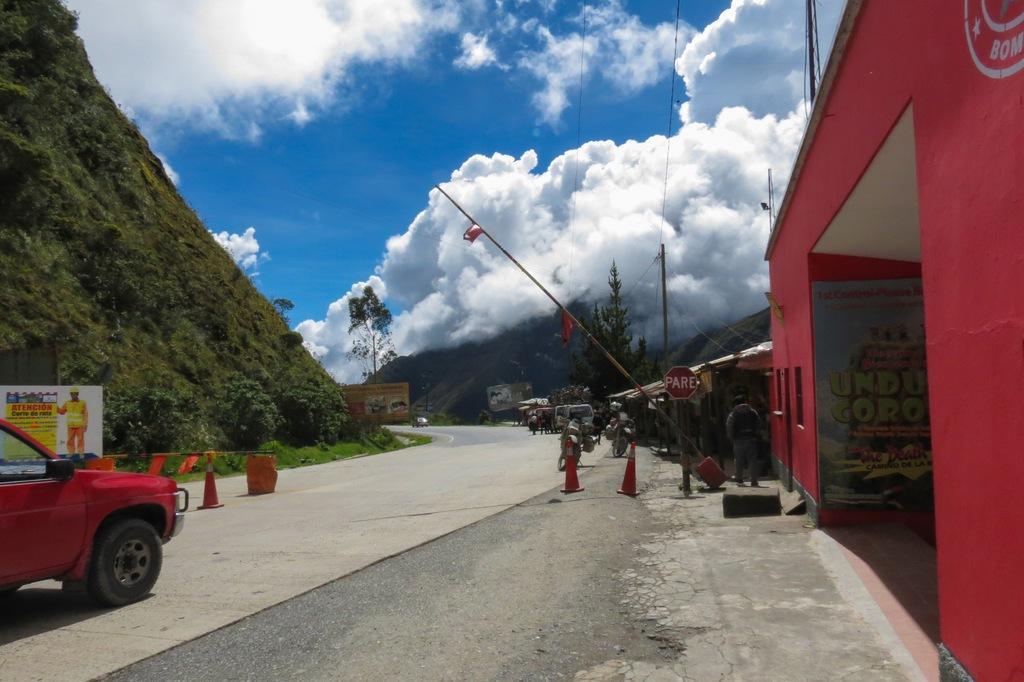Describe this image in one or two sentences. In this picture i can see vehicles on the road. On the right side i can see buildings, trees and poles. On the left side i can see traffic cones, hill and sky. 